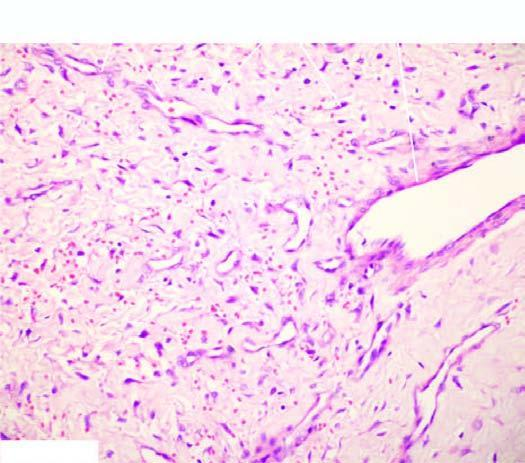does the tumour have stellate fibroblasts and mast cells?
Answer the question using a single word or phrase. No 